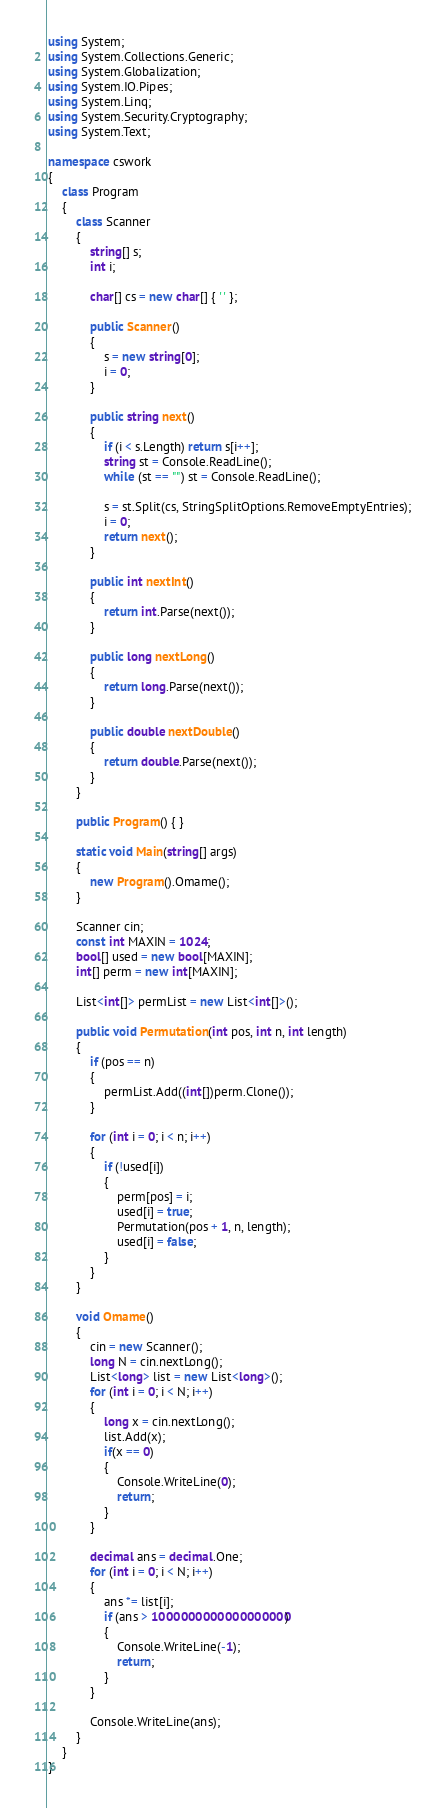<code> <loc_0><loc_0><loc_500><loc_500><_C#_>using System;
using System.Collections.Generic;
using System.Globalization;
using System.IO.Pipes;
using System.Linq;
using System.Security.Cryptography;
using System.Text;

namespace cswork
{
    class Program
    {
        class Scanner
        {
            string[] s;
            int i;

            char[] cs = new char[] { ' ' };

            public Scanner()
            {
                s = new string[0];
                i = 0;
            }

            public string next()
            {
                if (i < s.Length) return s[i++];
                string st = Console.ReadLine();
                while (st == "") st = Console.ReadLine();

                s = st.Split(cs, StringSplitOptions.RemoveEmptyEntries);
                i = 0;
                return next();
            }

            public int nextInt()
            {
                return int.Parse(next());
            }

            public long nextLong()
            {
                return long.Parse(next());
            }

            public double nextDouble()
            {
                return double.Parse(next());
            }
        }

        public Program() { }

        static void Main(string[] args)
        {
            new Program().Omame();
        }

        Scanner cin;
        const int MAXIN = 1024;
        bool[] used = new bool[MAXIN];
        int[] perm = new int[MAXIN];

        List<int[]> permList = new List<int[]>();

        public void Permutation(int pos, int n, int length)
        {
            if (pos == n)
            {
                permList.Add((int[])perm.Clone());
            }

            for (int i = 0; i < n; i++)
            {
                if (!used[i])
                {
                    perm[pos] = i;
                    used[i] = true;
                    Permutation(pos + 1, n, length);
                    used[i] = false;
                }
            }
        }

        void Omame()
        {
            cin = new Scanner();
            long N = cin.nextLong();
            List<long> list = new List<long>();
            for (int i = 0; i < N; i++)
            {
                long x = cin.nextLong();
                list.Add(x);
                if(x == 0)
                {
                    Console.WriteLine(0);
                    return;
                }
            }

            decimal ans = decimal.One;
            for (int i = 0; i < N; i++)
            {
                ans *= list[i];
                if (ans > 1000000000000000000)
                {
                    Console.WriteLine(-1);
                    return;
                }
            }

            Console.WriteLine(ans);
        }
    }
}
</code> 